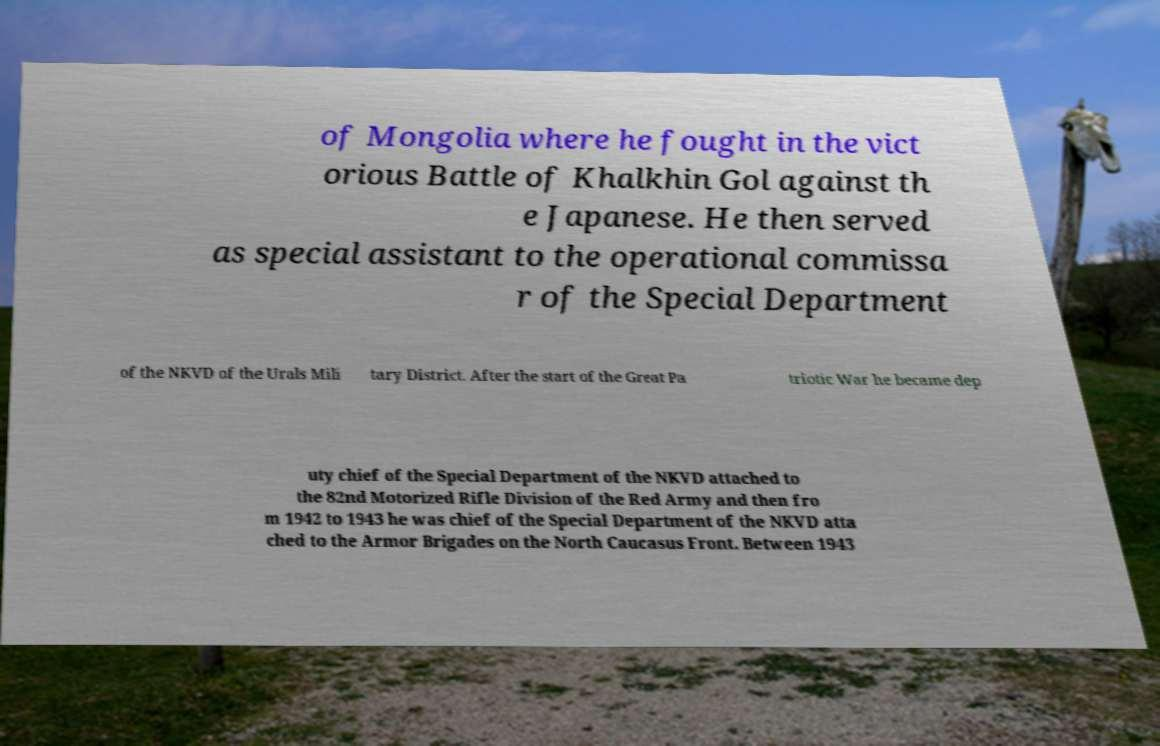Can you accurately transcribe the text from the provided image for me? of Mongolia where he fought in the vict orious Battle of Khalkhin Gol against th e Japanese. He then served as special assistant to the operational commissa r of the Special Department of the NKVD of the Urals Mili tary District. After the start of the Great Pa triotic War he became dep uty chief of the Special Department of the NKVD attached to the 82nd Motorized Rifle Division of the Red Army and then fro m 1942 to 1943 he was chief of the Special Department of the NKVD atta ched to the Armor Brigades on the North Caucasus Front. Between 1943 